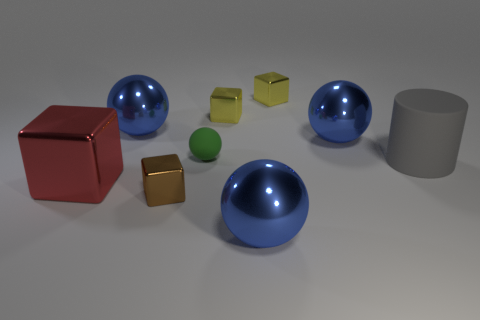Subtract all large blocks. How many blocks are left? 3 Subtract all blocks. How many objects are left? 5 Subtract all green balls. How many balls are left? 3 Add 1 brown blocks. How many objects exist? 10 Add 3 big metallic spheres. How many big metallic spheres are left? 6 Add 8 big yellow cubes. How many big yellow cubes exist? 8 Subtract 0 green cylinders. How many objects are left? 9 Subtract 4 spheres. How many spheres are left? 0 Subtract all brown blocks. Subtract all purple cylinders. How many blocks are left? 3 Subtract all yellow cylinders. How many red cubes are left? 1 